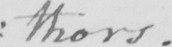Please provide the text content of this handwritten line. :thors. 